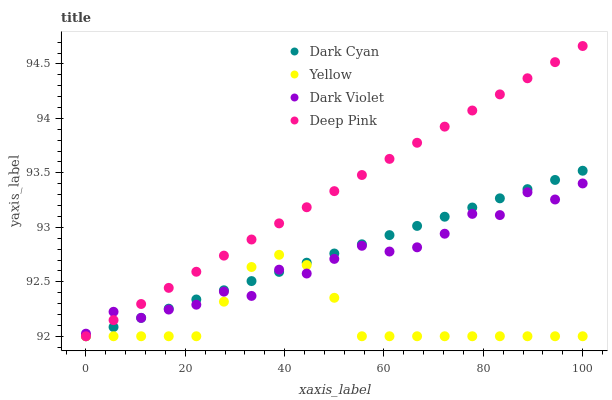Does Yellow have the minimum area under the curve?
Answer yes or no. Yes. Does Deep Pink have the maximum area under the curve?
Answer yes or no. Yes. Does Dark Violet have the minimum area under the curve?
Answer yes or no. No. Does Dark Violet have the maximum area under the curve?
Answer yes or no. No. Is Deep Pink the smoothest?
Answer yes or no. Yes. Is Dark Violet the roughest?
Answer yes or no. Yes. Is Dark Violet the smoothest?
Answer yes or no. No. Is Deep Pink the roughest?
Answer yes or no. No. Does Dark Cyan have the lowest value?
Answer yes or no. Yes. Does Dark Violet have the lowest value?
Answer yes or no. No. Does Deep Pink have the highest value?
Answer yes or no. Yes. Does Dark Violet have the highest value?
Answer yes or no. No. Does Dark Violet intersect Deep Pink?
Answer yes or no. Yes. Is Dark Violet less than Deep Pink?
Answer yes or no. No. Is Dark Violet greater than Deep Pink?
Answer yes or no. No. 